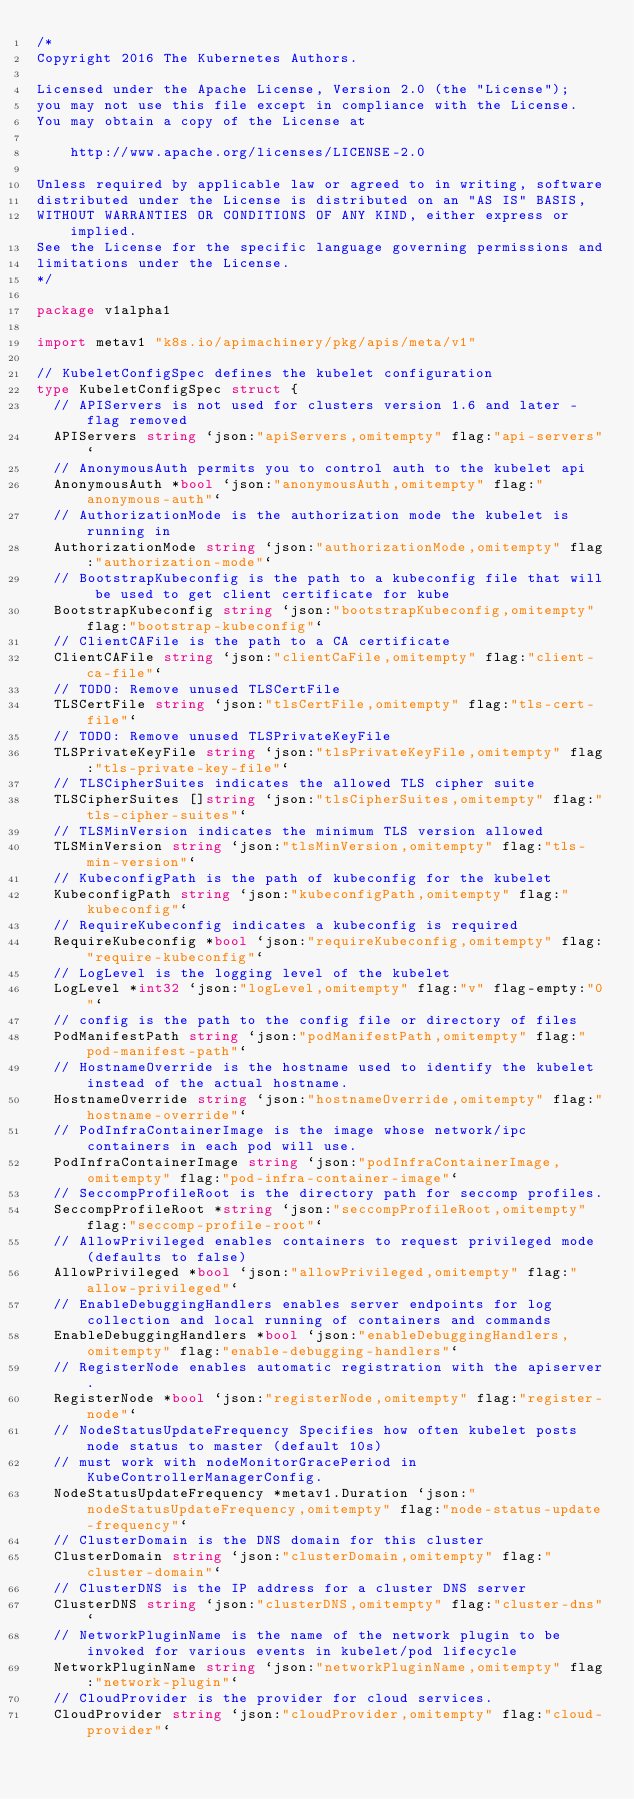Convert code to text. <code><loc_0><loc_0><loc_500><loc_500><_Go_>/*
Copyright 2016 The Kubernetes Authors.

Licensed under the Apache License, Version 2.0 (the "License");
you may not use this file except in compliance with the License.
You may obtain a copy of the License at

    http://www.apache.org/licenses/LICENSE-2.0

Unless required by applicable law or agreed to in writing, software
distributed under the License is distributed on an "AS IS" BASIS,
WITHOUT WARRANTIES OR CONDITIONS OF ANY KIND, either express or implied.
See the License for the specific language governing permissions and
limitations under the License.
*/

package v1alpha1

import metav1 "k8s.io/apimachinery/pkg/apis/meta/v1"

// KubeletConfigSpec defines the kubelet configuration
type KubeletConfigSpec struct {
	// APIServers is not used for clusters version 1.6 and later - flag removed
	APIServers string `json:"apiServers,omitempty" flag:"api-servers"`
	// AnonymousAuth permits you to control auth to the kubelet api
	AnonymousAuth *bool `json:"anonymousAuth,omitempty" flag:"anonymous-auth"`
	// AuthorizationMode is the authorization mode the kubelet is running in
	AuthorizationMode string `json:"authorizationMode,omitempty" flag:"authorization-mode"`
	// BootstrapKubeconfig is the path to a kubeconfig file that will be used to get client certificate for kube
	BootstrapKubeconfig string `json:"bootstrapKubeconfig,omitempty" flag:"bootstrap-kubeconfig"`
	// ClientCAFile is the path to a CA certificate
	ClientCAFile string `json:"clientCaFile,omitempty" flag:"client-ca-file"`
	// TODO: Remove unused TLSCertFile
	TLSCertFile string `json:"tlsCertFile,omitempty" flag:"tls-cert-file"`
	// TODO: Remove unused TLSPrivateKeyFile
	TLSPrivateKeyFile string `json:"tlsPrivateKeyFile,omitempty" flag:"tls-private-key-file"`
	// TLSCipherSuites indicates the allowed TLS cipher suite
	TLSCipherSuites []string `json:"tlsCipherSuites,omitempty" flag:"tls-cipher-suites"`
	// TLSMinVersion indicates the minimum TLS version allowed
	TLSMinVersion string `json:"tlsMinVersion,omitempty" flag:"tls-min-version"`
	// KubeconfigPath is the path of kubeconfig for the kubelet
	KubeconfigPath string `json:"kubeconfigPath,omitempty" flag:"kubeconfig"`
	// RequireKubeconfig indicates a kubeconfig is required
	RequireKubeconfig *bool `json:"requireKubeconfig,omitempty" flag:"require-kubeconfig"`
	// LogLevel is the logging level of the kubelet
	LogLevel *int32 `json:"logLevel,omitempty" flag:"v" flag-empty:"0"`
	// config is the path to the config file or directory of files
	PodManifestPath string `json:"podManifestPath,omitempty" flag:"pod-manifest-path"`
	// HostnameOverride is the hostname used to identify the kubelet instead of the actual hostname.
	HostnameOverride string `json:"hostnameOverride,omitempty" flag:"hostname-override"`
	// PodInfraContainerImage is the image whose network/ipc containers in each pod will use.
	PodInfraContainerImage string `json:"podInfraContainerImage,omitempty" flag:"pod-infra-container-image"`
	// SeccompProfileRoot is the directory path for seccomp profiles.
	SeccompProfileRoot *string `json:"seccompProfileRoot,omitempty" flag:"seccomp-profile-root"`
	// AllowPrivileged enables containers to request privileged mode (defaults to false)
	AllowPrivileged *bool `json:"allowPrivileged,omitempty" flag:"allow-privileged"`
	// EnableDebuggingHandlers enables server endpoints for log collection and local running of containers and commands
	EnableDebuggingHandlers *bool `json:"enableDebuggingHandlers,omitempty" flag:"enable-debugging-handlers"`
	// RegisterNode enables automatic registration with the apiserver.
	RegisterNode *bool `json:"registerNode,omitempty" flag:"register-node"`
	// NodeStatusUpdateFrequency Specifies how often kubelet posts node status to master (default 10s)
	// must work with nodeMonitorGracePeriod in KubeControllerManagerConfig.
	NodeStatusUpdateFrequency *metav1.Duration `json:"nodeStatusUpdateFrequency,omitempty" flag:"node-status-update-frequency"`
	// ClusterDomain is the DNS domain for this cluster
	ClusterDomain string `json:"clusterDomain,omitempty" flag:"cluster-domain"`
	// ClusterDNS is the IP address for a cluster DNS server
	ClusterDNS string `json:"clusterDNS,omitempty" flag:"cluster-dns"`
	// NetworkPluginName is the name of the network plugin to be invoked for various events in kubelet/pod lifecycle
	NetworkPluginName string `json:"networkPluginName,omitempty" flag:"network-plugin"`
	// CloudProvider is the provider for cloud services.
	CloudProvider string `json:"cloudProvider,omitempty" flag:"cloud-provider"`</code> 